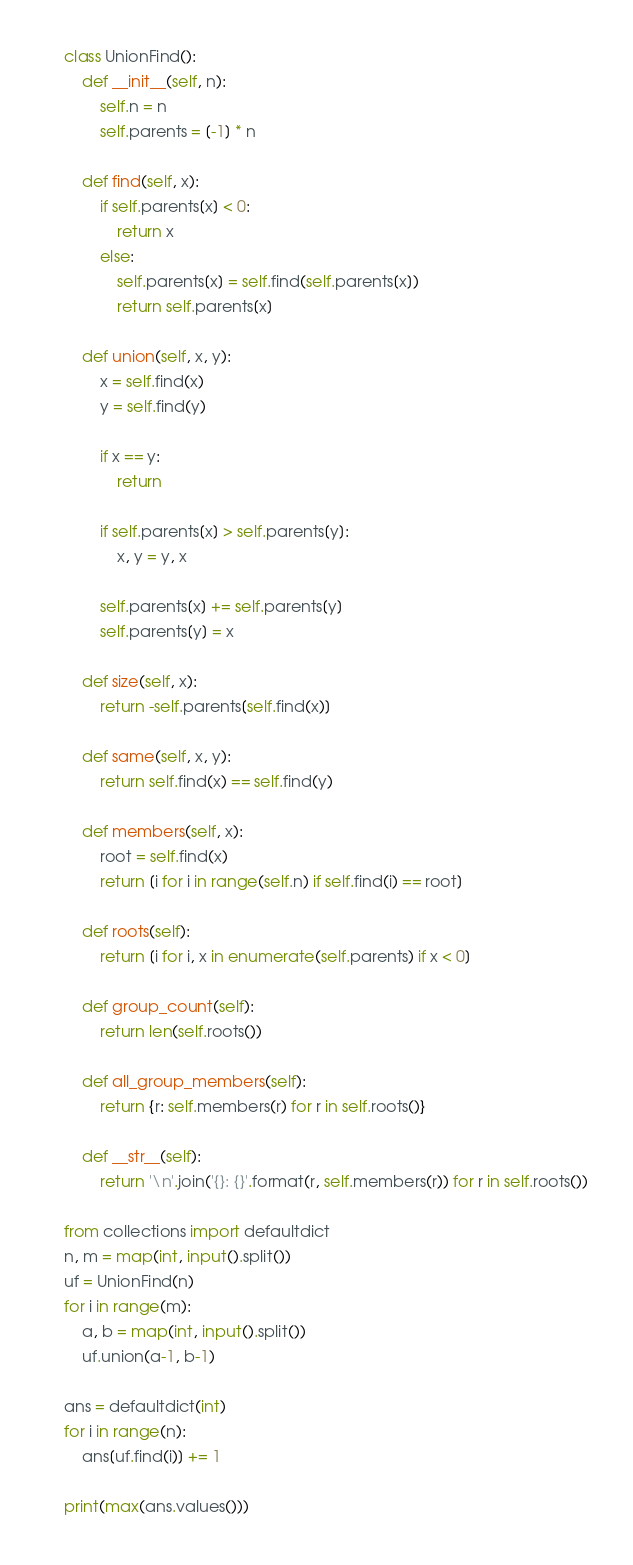Convert code to text. <code><loc_0><loc_0><loc_500><loc_500><_Python_>class UnionFind():
    def __init__(self, n):
        self.n = n
        self.parents = [-1] * n

    def find(self, x):
        if self.parents[x] < 0:
            return x
        else:
            self.parents[x] = self.find(self.parents[x])
            return self.parents[x]

    def union(self, x, y):
        x = self.find(x)
        y = self.find(y)

        if x == y:
            return

        if self.parents[x] > self.parents[y]:
            x, y = y, x

        self.parents[x] += self.parents[y]
        self.parents[y] = x

    def size(self, x):
        return -self.parents[self.find(x)]

    def same(self, x, y):
        return self.find(x) == self.find(y)

    def members(self, x):
        root = self.find(x)
        return [i for i in range(self.n) if self.find(i) == root]

    def roots(self):
        return [i for i, x in enumerate(self.parents) if x < 0]

    def group_count(self):
        return len(self.roots())

    def all_group_members(self):
        return {r: self.members(r) for r in self.roots()}

    def __str__(self):
        return '\n'.join('{}: {}'.format(r, self.members(r)) for r in self.roots())

from collections import defaultdict
n, m = map(int, input().split())
uf = UnionFind(n)
for i in range(m):
    a, b = map(int, input().split())
    uf.union(a-1, b-1)

ans = defaultdict(int)
for i in range(n):
    ans[uf.find(i)] += 1

print(max(ans.values()))</code> 